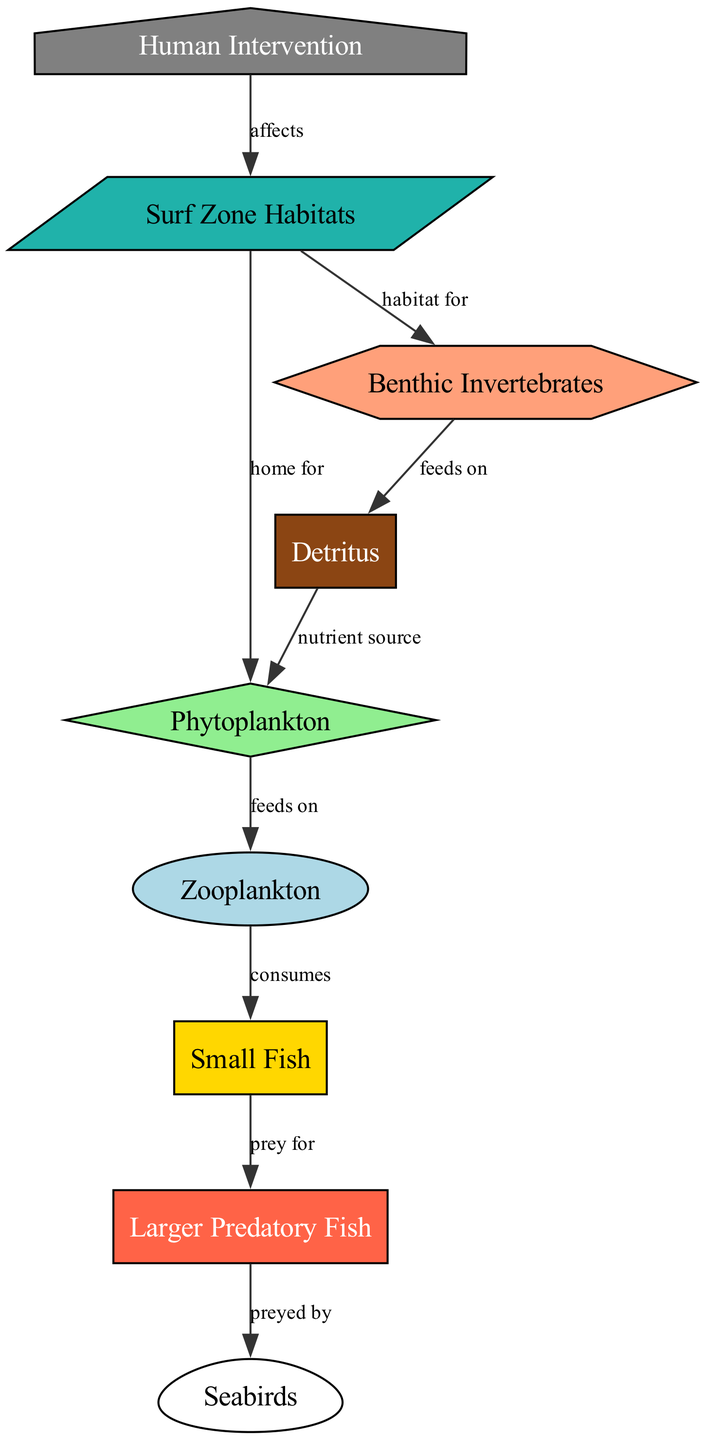What is the source of nutrients for phytoplankton? The edge from "detritus" to "phytoplankton" is labeled "nutrient source", indicating that detritus provides nutrients to phytoplankton.
Answer: detritus How many total nodes are in the diagram? Counting the nodes listed in the data, we have: phytoplankton, zooplankton, small fish, larger predatory fish, seabirds, detritus, benthic invertebrates, human intervention, surf zone habitats, which sums up to nine nodes.
Answer: 9 Which organism does small fish serve as prey for? The arrow from "small fish" to "larger predatory fish" is labeled "prey for", indicating that small fish are consumed by larger predatory fish.
Answer: larger predatory fish What role do surf zone habitats play for benthic invertebrates? The edge connecting "surf zone habitats" to "benthic invertebrates" is labeled "habitat for", showing that surf zone habitats provide a habitat for benthic invertebrates.
Answer: habitat for What impact does human intervention have in the diagram? The directed edge from "human intervention" to "surf zone habitats" is labeled "affects", indicating that human intervention has an impact on surf zone habitats.
Answer: affects What animal preys on larger predatory fish? The arrow from "larger predatory fish" to "seabirds" is labeled "preyed by", showing that seabirds prey on larger predatory fish.
Answer: seabirds Which two groups feed on phytoplankton? The diagram indicates that both "zooplankton" (feeds on) and "detritus" (as nutrient source) are connected to phytoplankton, with detritus providing nutrients.
Answer: zooplankton and detritus What type of relationship exists between detritus and benthic invertebrates? The connection from "benthic invertebrates" to "detritus" is labeled "feeds on", indicating that benthic invertebrates consume detritus.
Answer: feeds on Who consumes zooplankton? The edge from "zooplankton" to "small fish" is labeled "consumes", indicating that small fish consume zooplankton.
Answer: small fish 